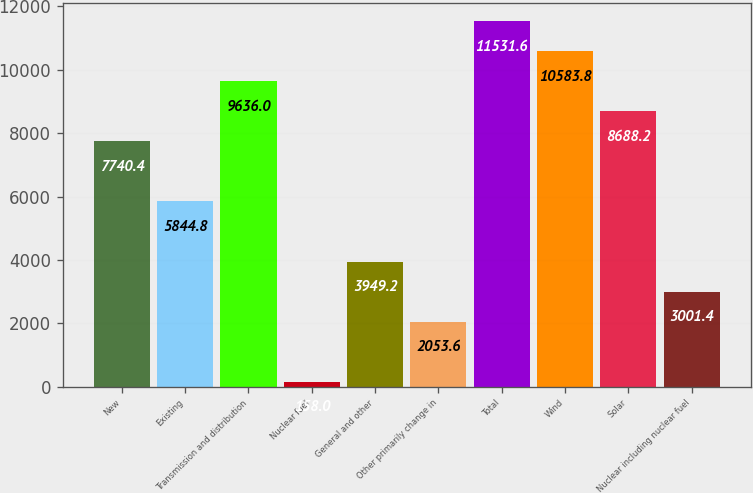Convert chart to OTSL. <chart><loc_0><loc_0><loc_500><loc_500><bar_chart><fcel>New<fcel>Existing<fcel>Transmission and distribution<fcel>Nuclear fuel<fcel>General and other<fcel>Other primarily change in<fcel>Total<fcel>Wind<fcel>Solar<fcel>Nuclear including nuclear fuel<nl><fcel>7740.4<fcel>5844.8<fcel>9636<fcel>158<fcel>3949.2<fcel>2053.6<fcel>11531.6<fcel>10583.8<fcel>8688.2<fcel>3001.4<nl></chart> 